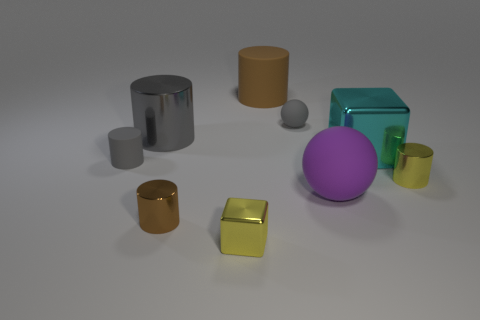Is the number of tiny gray matte cylinders that are in front of the brown shiny thing less than the number of cylinders behind the large ball?
Your response must be concise. Yes. Is there anything else that has the same shape as the brown metal object?
Keep it short and to the point. Yes. Does the large gray thing have the same shape as the tiny brown metallic object?
Give a very brief answer. Yes. The yellow cylinder is what size?
Offer a very short reply. Small. What is the color of the thing that is to the right of the small gray cylinder and to the left of the brown metallic cylinder?
Give a very brief answer. Gray. Are there more large purple shiny objects than big brown cylinders?
Provide a short and direct response. No. How many things are green rubber cubes or metal objects to the left of the big brown cylinder?
Your response must be concise. 3. Do the gray sphere and the yellow cylinder have the same size?
Give a very brief answer. Yes. There is a small brown metallic object; are there any big cylinders to the left of it?
Offer a terse response. Yes. What is the size of the matte thing that is in front of the large brown rubber cylinder and behind the large metallic block?
Offer a terse response. Small. 